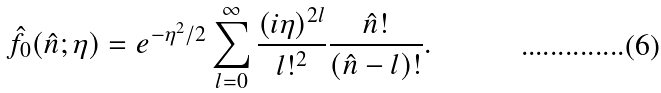Convert formula to latex. <formula><loc_0><loc_0><loc_500><loc_500>\hat { f } _ { 0 } ( \hat { n } ; \eta ) = e ^ { - \eta ^ { 2 } / 2 } \sum _ { l = 0 } ^ { \infty } \frac { ( i \eta ) ^ { 2 l } } { l ! ^ { 2 } } \frac { \hat { n } ! } { ( \hat { n } - l ) ! } .</formula> 